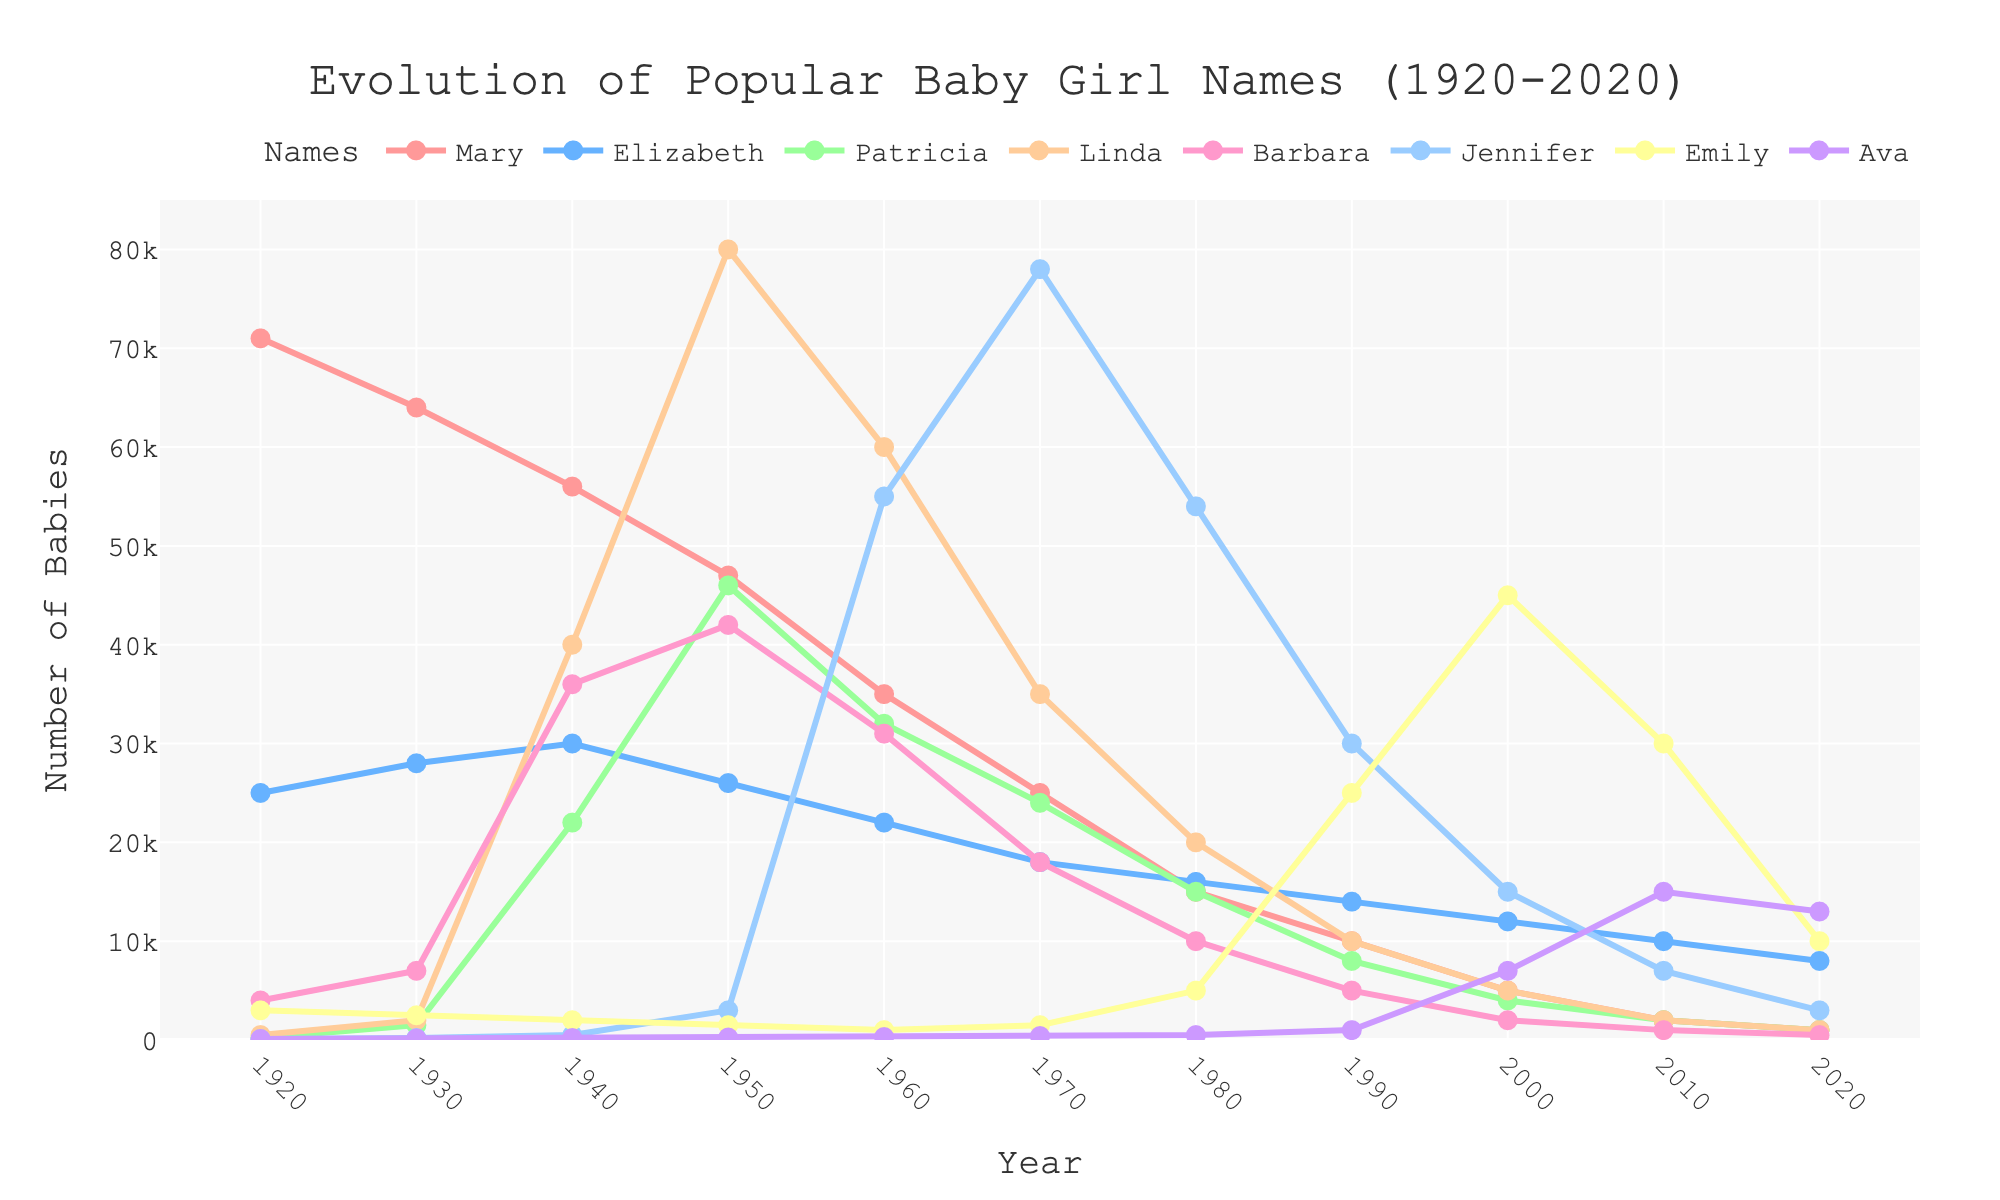What was the highest number of babies named Jennifer, and in which year did it occur? To find this, look at the peaks of the "Jennifer" line in the chart. The peak value for Jennifer appears in the decade of the 1970s. The corresponding year at this peak is 1970, and the number is 78,000.
Answer: 78,000 in 1970 Which name had the highest number of babies in any given year, and what was that number? Scan all the lines for their highest points. The highest peak among all names is for Linda in 1950, reaching approximately 80,000.
Answer: Linda, 80,000 How did the popularity of the name 'Mary' change from 1920 to 2020? Check the two endpoints of the line representing Mary. In 1920, it was 71,000, and in 2020 it was 1,000. Thus, the popularity significantly declined.
Answer: Decreased from 71,000 to 1,000 What's the average number of babies named Elizabeth over the given years? Add all the baby counts for Elizabeth from each year and divide by the number of years (11). The counts are: 25,000, 28,000, 30,000, 26,000, 22,000, 18,000, 16,000, 14,000, 12,000, 10,000, and 8,000. Their sum is 209,000, so the average is 209,000 / 11 = 19,000.
Answer: 19,000 Which name showed the most consistent increase in popularity from 1920 to 2020? Examine the overall trajectory of each name's line on the chart. Among the lines, Ava consistently increases, starting from almost 100 in 1920 to 13,000 in 2020, showing an overall upward trend.
Answer: Ava Compare the popularity of Patricia and Linda in 1950. Which name was more popular and by how much? In 1950, Patricia had 46,000 babies named, and Linda had 80,000 babies named. The difference is 80,000 - 46,000 = 34,000, so Linda was more popular by 34,000.
Answer: Linda, by 34,000 Identify a year where the name Emily had a notable rise compared to previous years. Observe the chart for Emily and identify any sharp increase. Between 1980 and 1990, there is a significant rise from around 5,000 to 25,000.
Answer: 1990 Which two names had the highest counts in 1920? Look at the values on the chart at 1920. Mary had 71,000, and Elizabeth had 25,000, which are the highest counts.
Answer: Mary and Elizabeth Which name's popularity remained relatively low (below 10,000) throughout the entire period? Identify lines that stay below 10,000 across all years. Barbara remains consistently lower than 10,000 in 2020 but was significantly higher in earlier years, making "Patricia" and "Linda" more valid candidates for lower sustained values. Ava is the most consistent, staying below 10,000 until the last decade, similarly "Jennifer" after 1970 shows a sharp decline but starts below 1950.
Answer: Ava Have any names dropped to zero by the year 2020? Look at the endpoints for all lines in 2020. None of the names drop to zero in 2020, with the majority of counts for names like Mary and Barbara still above 1,000.
Answer: None 